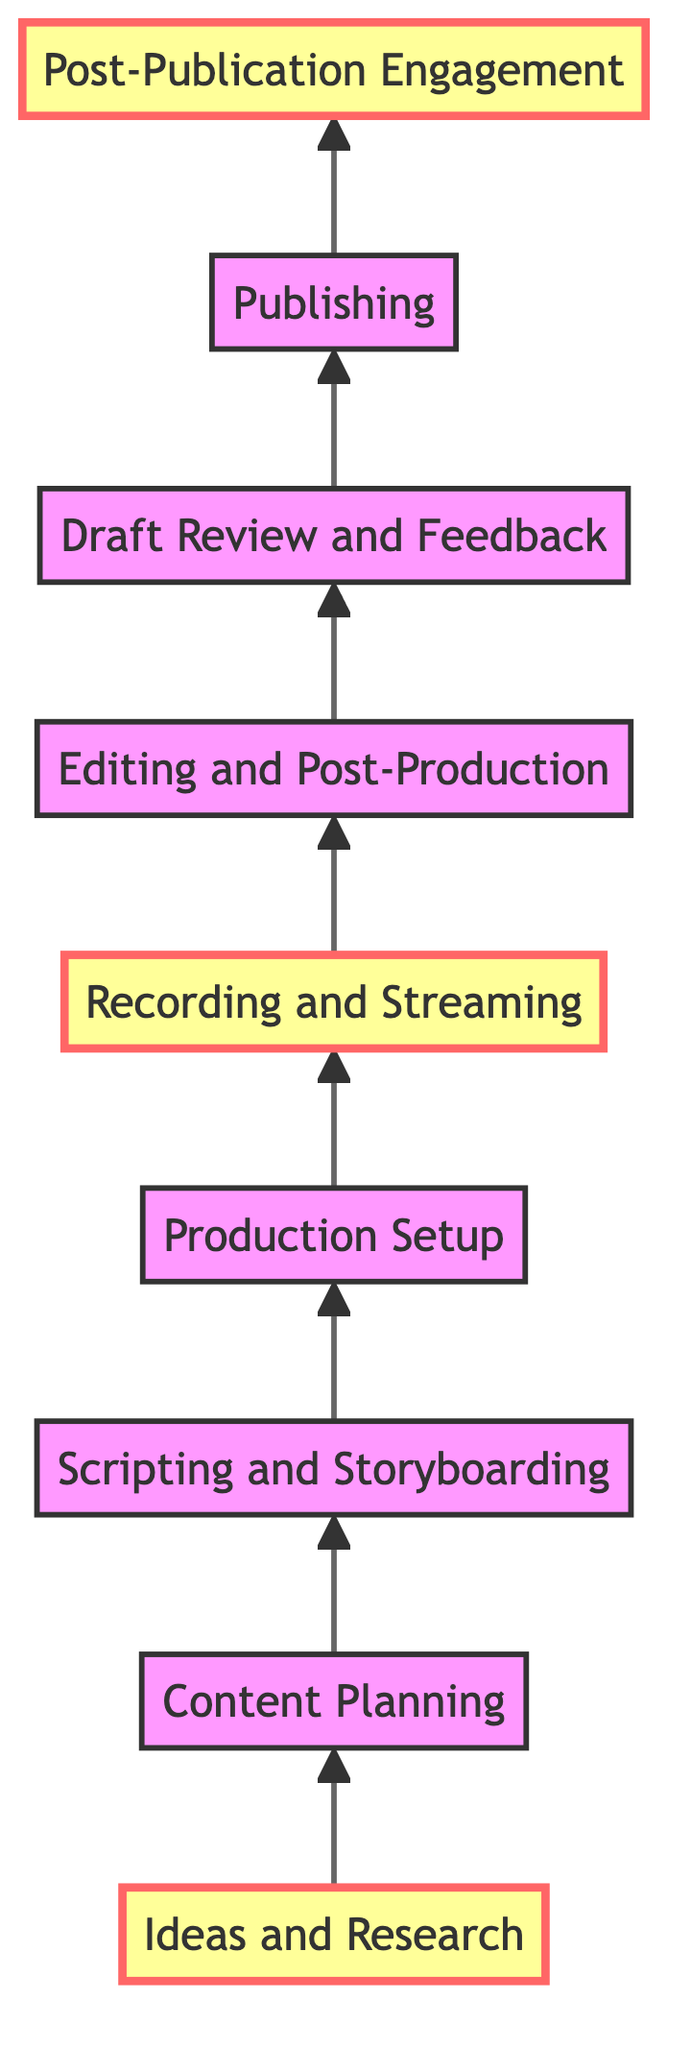What is the first step in the content creation pipeline? The first step in the pipeline, as indicated by the bottom node, is "Ideas and Research." This is the starting point where brainstorming occurs.
Answer: Ideas and Research How many steps are there in total in the content creation pipeline? Counting all the nodes in the diagram from bottom to top, there are a total of 9 steps in the pipeline.
Answer: 9 Which step follows "Editing and Post-Production"? The diagram shows that "Draft Review and Feedback" directly follows "Editing and Post-Production," which indicates the sequential flow of the content process.
Answer: Draft Review and Feedback What are the two highlighted steps in the diagram? The highlighted steps are "Ideas and Research" at the bottom and "Recording and Streaming" in the middle, along with "Post-Publication Engagement" at the top, emphasizing these key stages in the process.
Answer: Ideas and Research, Recording and Streaming, Post-Publication Engagement Which two steps are directly connected to "Scripting and Storyboarding"? The diagram shows that "Scripting and Storyboarding" is directly connected to "Content Planning" below it and "Production Setup" above it, forming part of the workflow in content creation.
Answer: Content Planning, Production Setup What is the last step of the process? At the top of the flow chart is "Post-Publication Engagement," which is the final step in the content creation process after publishing.
Answer: Post-Publication Engagement Which stage involves configuring equipment? The stage that involves configuring the equipment is "Production Setup," where the necessary tools for production quality are arranged and tested.
Answer: Production Setup How does "Recording and Streaming" relate to "Editing and Post-Production"? "Recording and Streaming" directly precedes "Editing and Post-Production," indicating that content must first be recorded before it can be edited and refined.
Answer: Recording and Streaming What action follows the "Draft Review and Feedback"? The action that follows "Draft Review and Feedback" in the flow is "Publishing," where the finalized content is released to the audience.
Answer: Publishing 